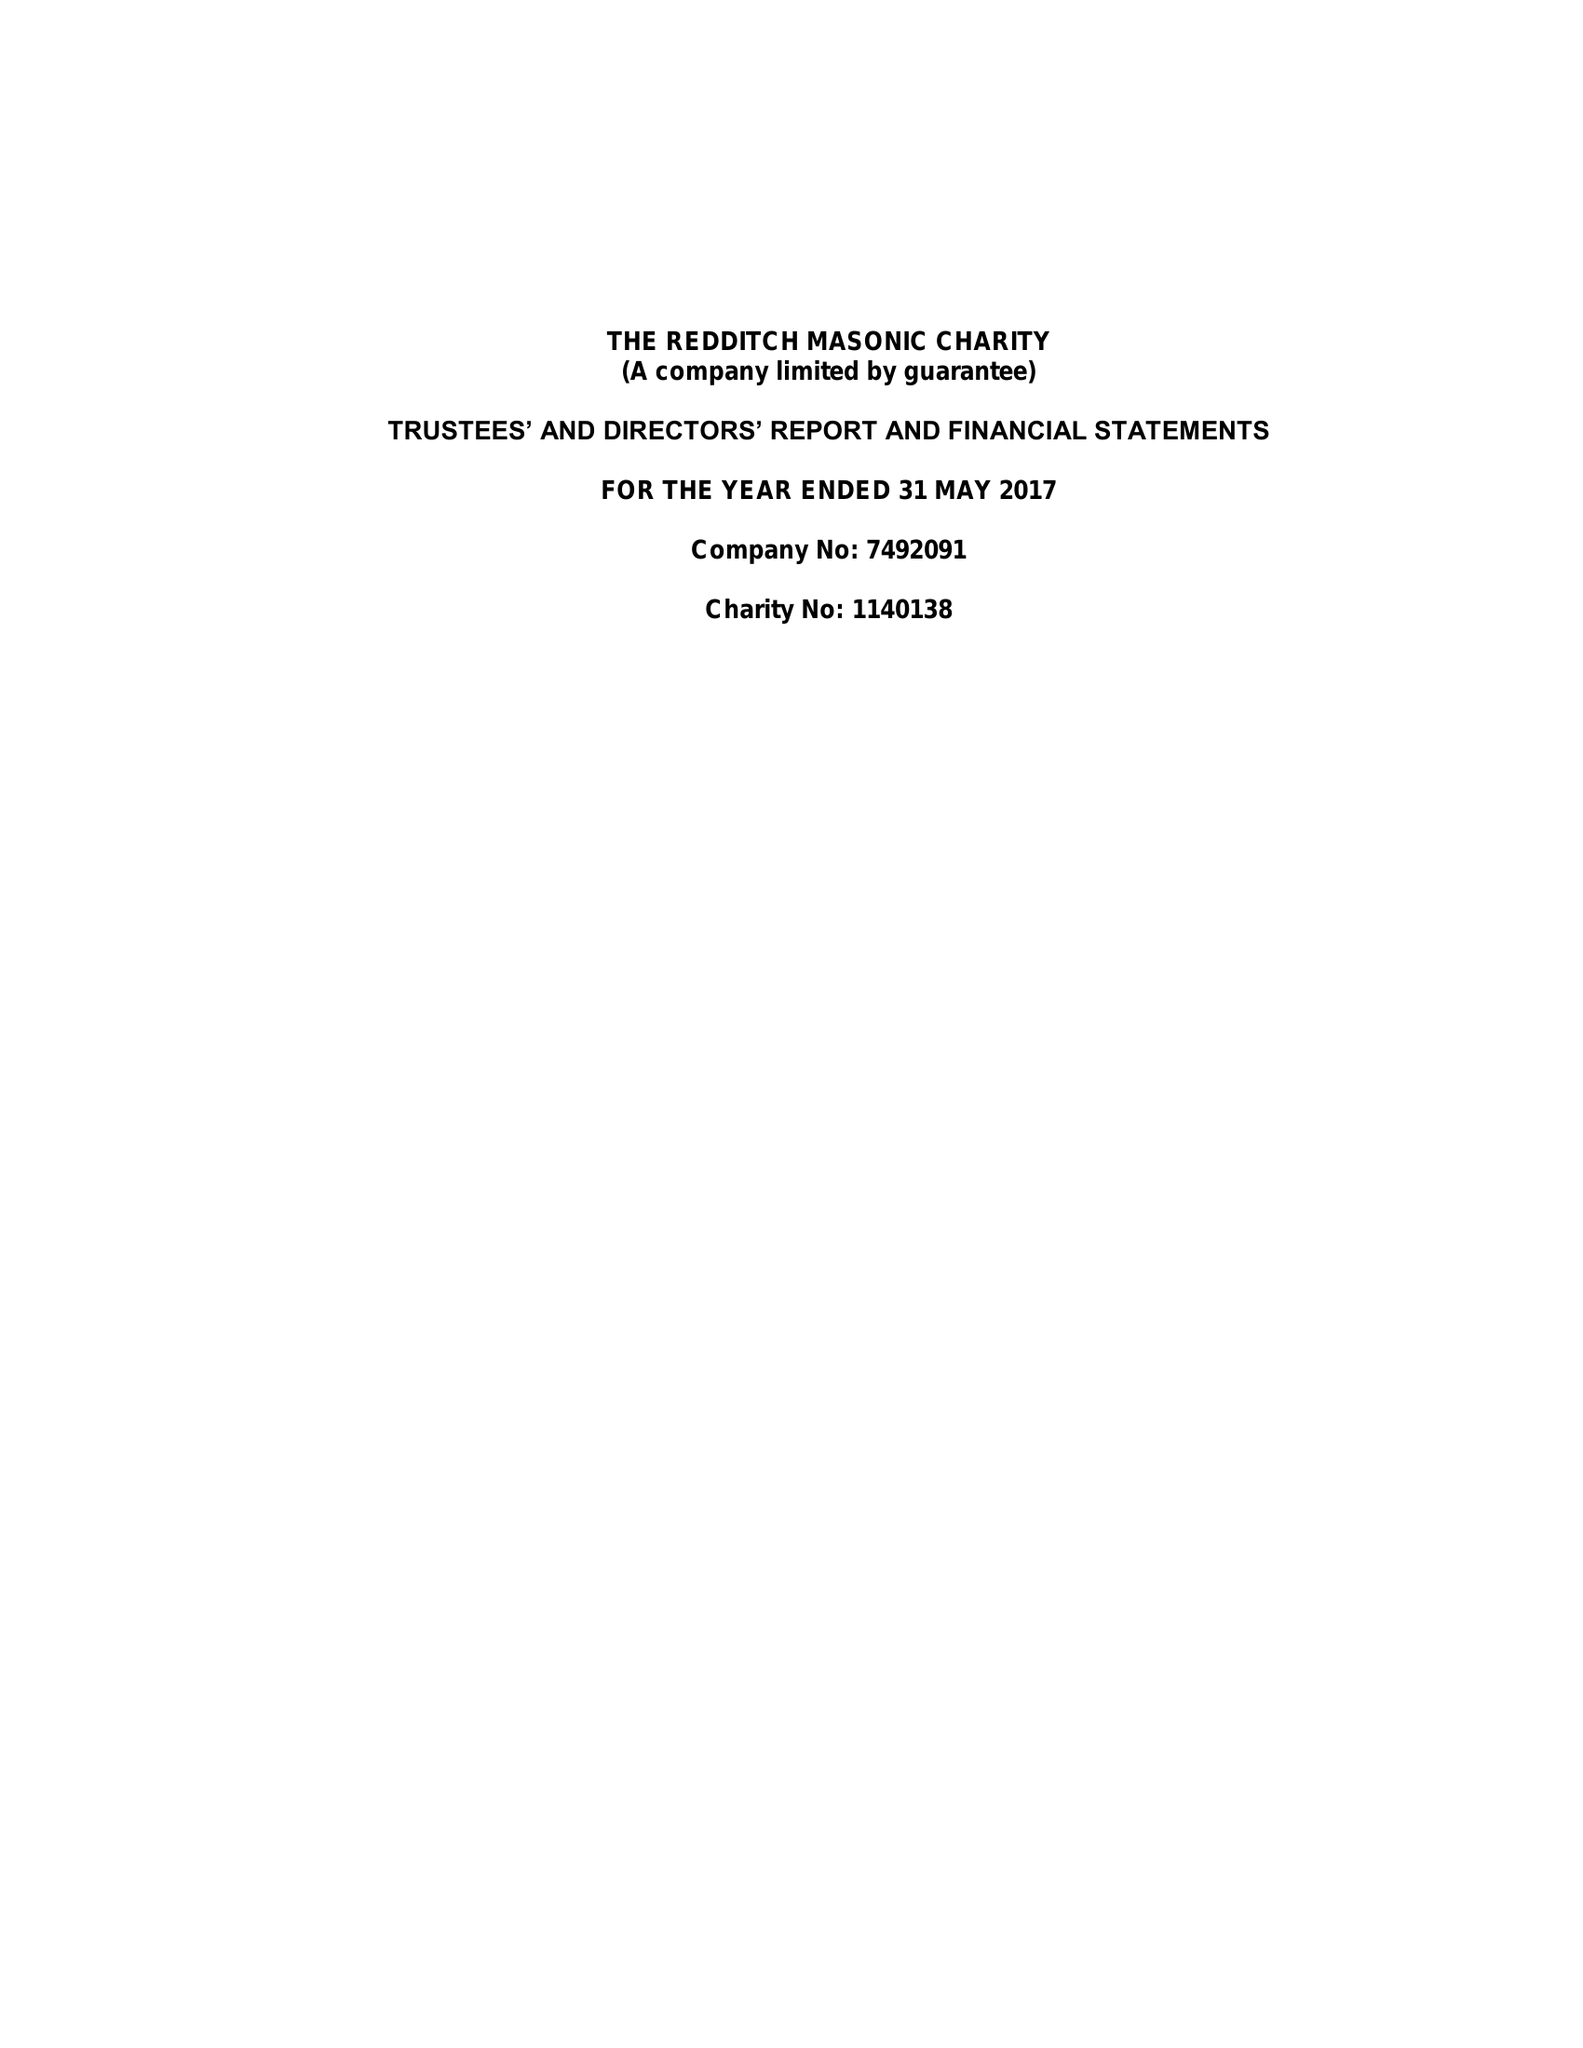What is the value for the income_annually_in_british_pounds?
Answer the question using a single word or phrase. 48279.00 